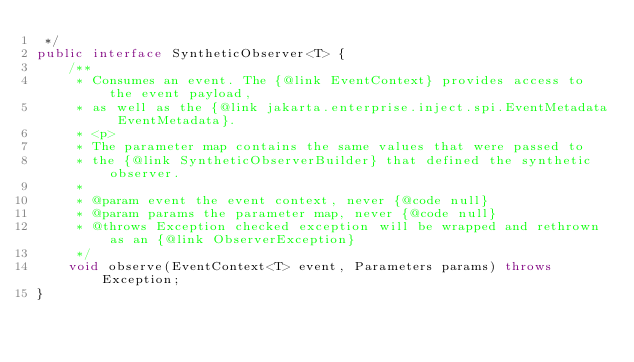Convert code to text. <code><loc_0><loc_0><loc_500><loc_500><_Java_> */
public interface SyntheticObserver<T> {
    /**
     * Consumes an event. The {@link EventContext} provides access to the event payload,
     * as well as the {@link jakarta.enterprise.inject.spi.EventMetadata EventMetadata}.
     * <p>
     * The parameter map contains the same values that were passed to
     * the {@link SyntheticObserverBuilder} that defined the synthetic observer.
     *
     * @param event the event context, never {@code null}
     * @param params the parameter map, never {@code null}
     * @throws Exception checked exception will be wrapped and rethrown as an {@link ObserverException}
     */
    void observe(EventContext<T> event, Parameters params) throws Exception;
}
</code> 